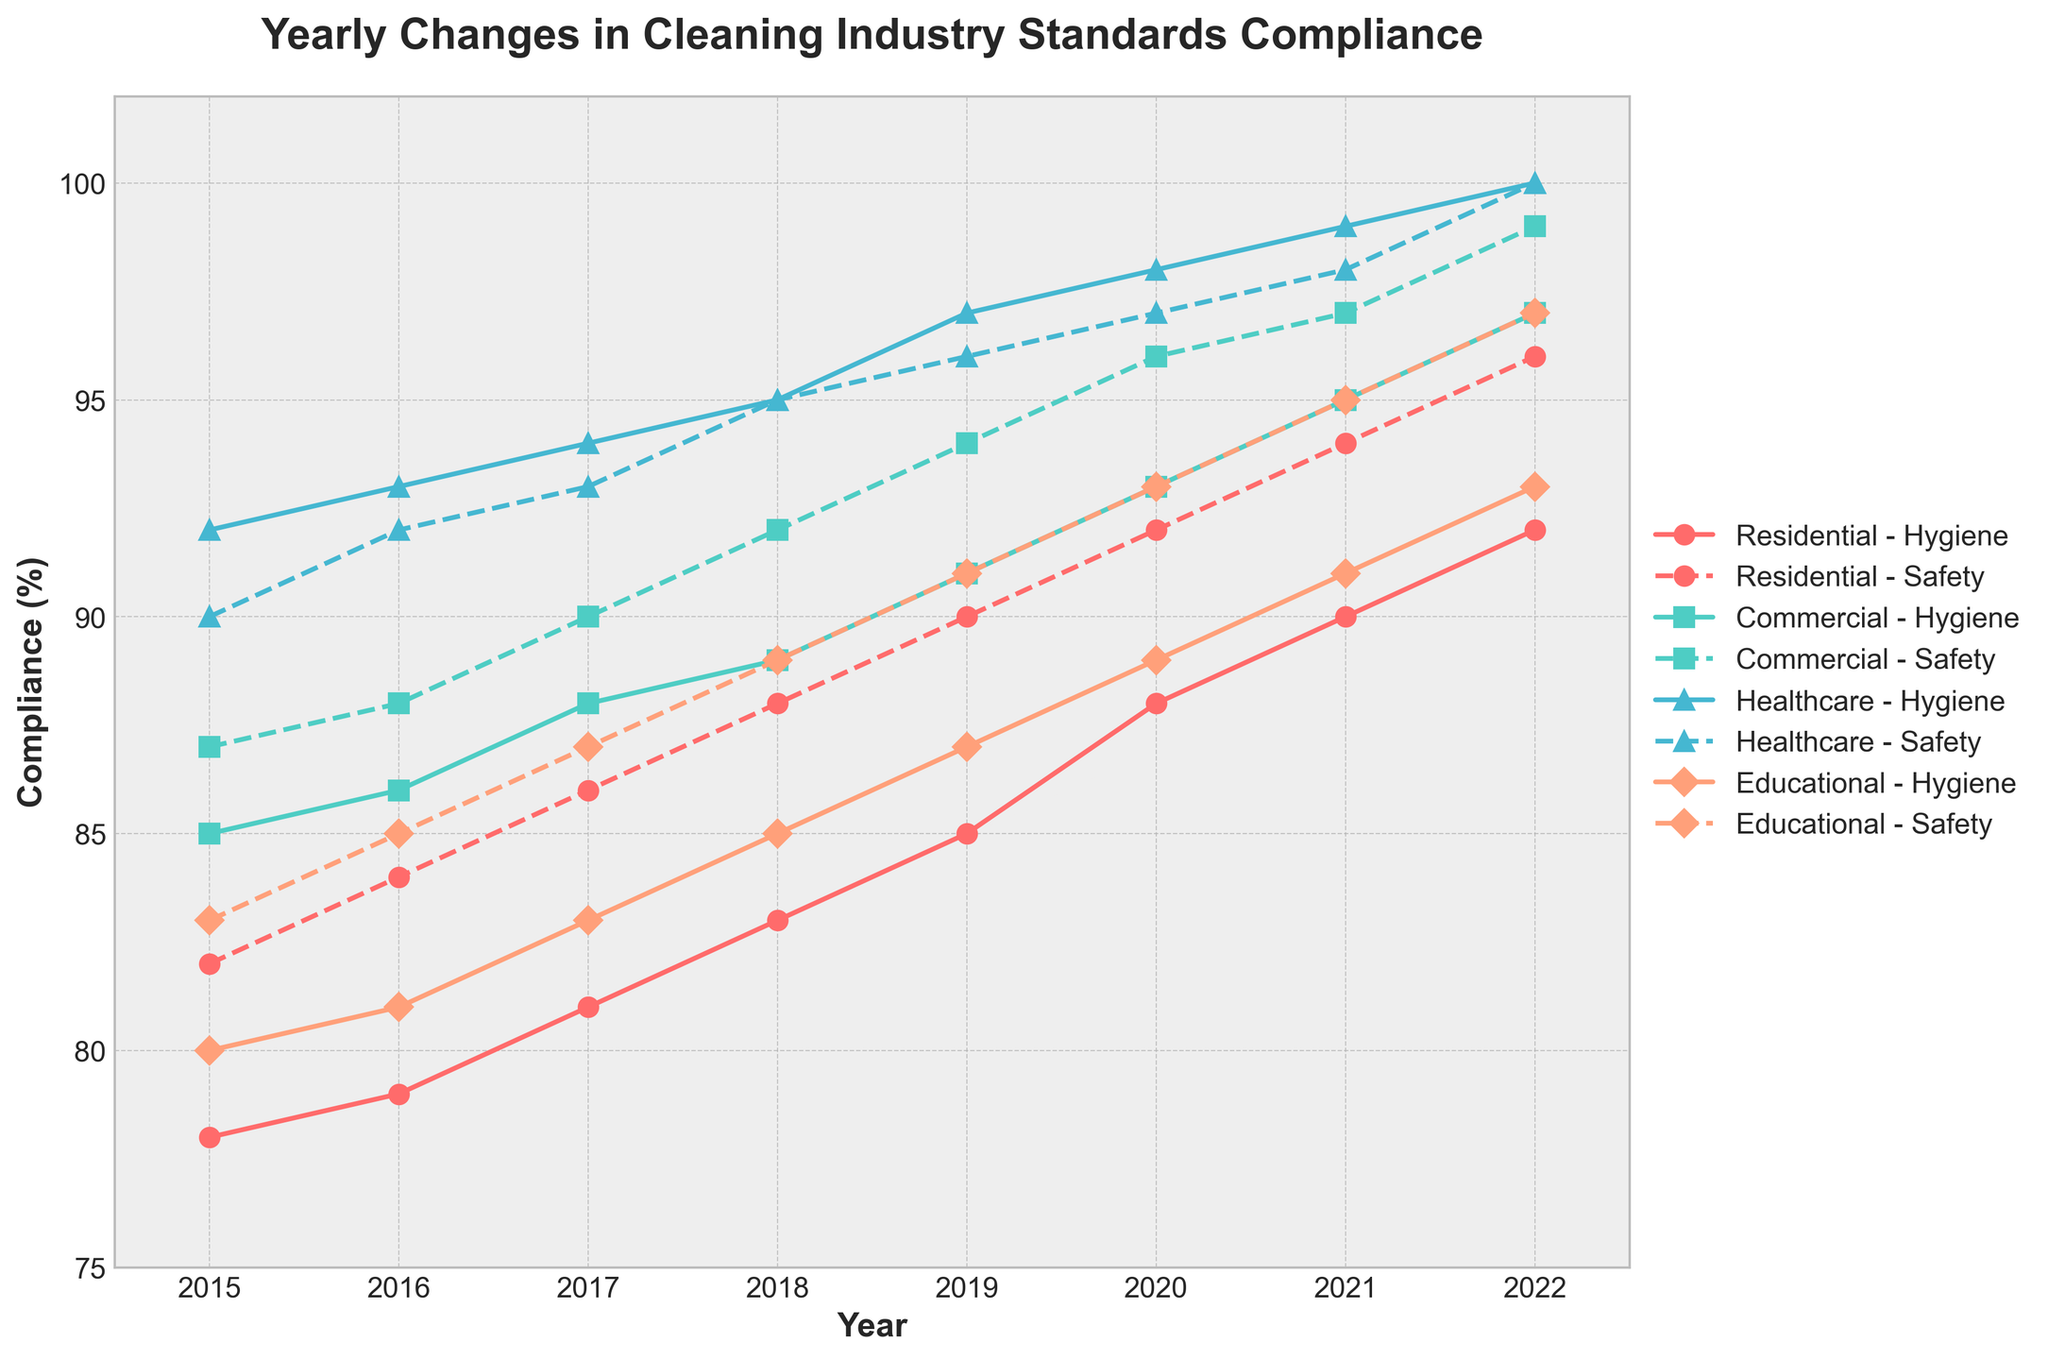What's the title of the figure? The title can be found at the top of the plot. It reads "Yearly Changes in Cleaning Industry Standards Compliance".
Answer: Yearly Changes in Cleaning Industry Standards Compliance What are the axes labels of the figure? The labels of the axes are written alongside them. The x-axis is labeled "Year" and the y-axis is labeled "Compliance (%)".
Answer: Year; Compliance (%) Which building type has consistently the highest hygiene standards compliance from 2015 to 2022? By following the hygiene standards compliance lines for all building types in the plot, we can see that Healthcare consistently has the highest values each year.
Answer: Healthcare In what year did residential buildings first reach a hygiene standards compliance of 90%? Following the line for Residential Hygiene Standards Compliance, the first year it reached 90% is 2021.
Answer: 2021 When did safety guidelines compliance in commercial buildings reach 99%? Checking the line for Safety Guidelines Compliance for commercial buildings, we see that it reached 99% in 2022.
Answer: 2022 How much did the hygiene standards compliance in educational buildings improve between 2015 and 2022? Subtract the hygiene standards compliance in educational buildings in 2015 (80%) from that in 2022 (93%). The calculation is 93 - 80 = 13.
Answer: 13% Which building type showed the greatest improvement in safety guidelines compliance from 2015 to 2022? Comparing the total growth between 2015 and 2022 for each building type, Healthcare increased from 90% to 100%, an increase of 10%.
Answer: Healthcare What is the average hygiene standards compliance for residential buildings from 2015 to 2022? Add up the hygiene standards compliance values for residential buildings (78, 79, 81, 83, 85, 88, 90, 92) and divide by 8. The calculation is (78 + 79 + 81 + 83 + 85 + 88 + 90 + 92) / 8 = 84.5.
Answer: 84.5% Did any building type reach 100% compliance for any standard by 2022? The lines show that Healthcare buildings reached 100% compliance in both Hygiene Standards Compliance and Safety Guidelines Compliance by 2022.
Answer: Yes Which building showed the smallest increase in hygiene standards compliance between 2015 and 2022? By calculating the increase for each type, Residential increased from 78% to 92% (14%), Commercial from 85% to 97% (12%), Healthcare from 92% to 100% (8%), and Educational from 80% to 93% (13%). Healthcare shows the smallest increase of 8%.
Answer: Healthcare 